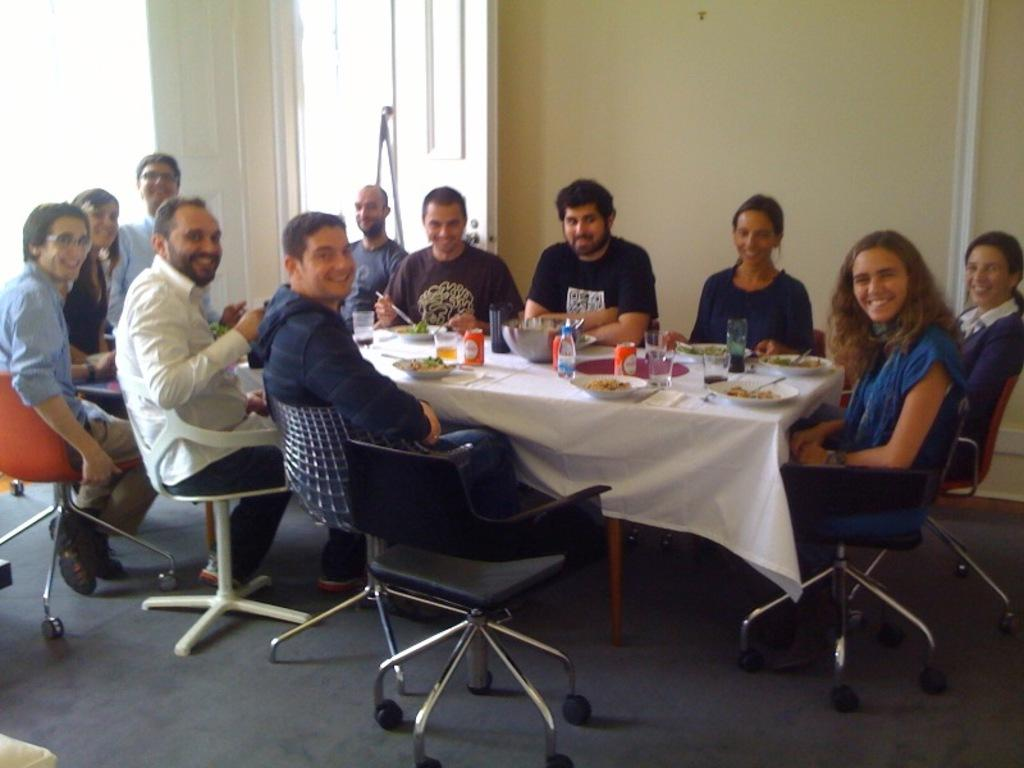What is happening in the image involving a group of people? There is a group of people in the image, and they are seated on chairs. What can be found on the table in the image? There are food bowls, water bottles, and plates on the table. How are the people arranged in the image? The people are seated on chairs in the image. What type of van is parked in the background of the image? There is no van present in the image; it only features a group of people seated on chairs and items on the table. 